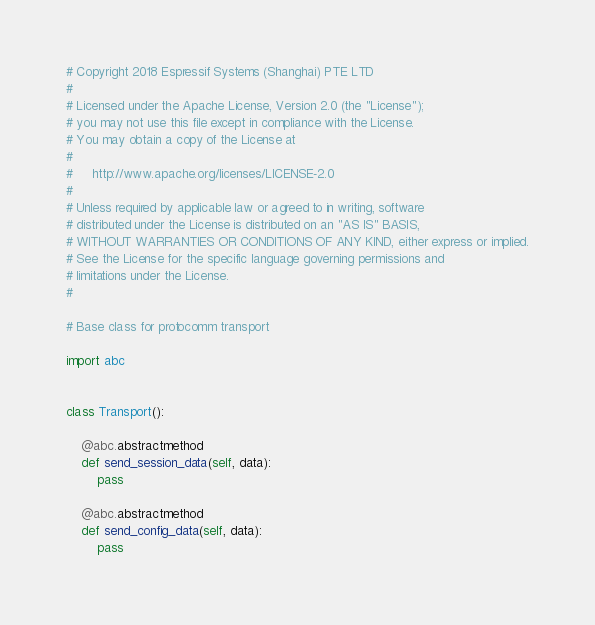<code> <loc_0><loc_0><loc_500><loc_500><_Python_># Copyright 2018 Espressif Systems (Shanghai) PTE LTD
#
# Licensed under the Apache License, Version 2.0 (the "License");
# you may not use this file except in compliance with the License.
# You may obtain a copy of the License at
#
#     http://www.apache.org/licenses/LICENSE-2.0
#
# Unless required by applicable law or agreed to in writing, software
# distributed under the License is distributed on an "AS IS" BASIS,
# WITHOUT WARRANTIES OR CONDITIONS OF ANY KIND, either express or implied.
# See the License for the specific language governing permissions and
# limitations under the License.
#

# Base class for protocomm transport

import abc


class Transport():

    @abc.abstractmethod
    def send_session_data(self, data):
        pass

    @abc.abstractmethod
    def send_config_data(self, data):
        pass
</code> 